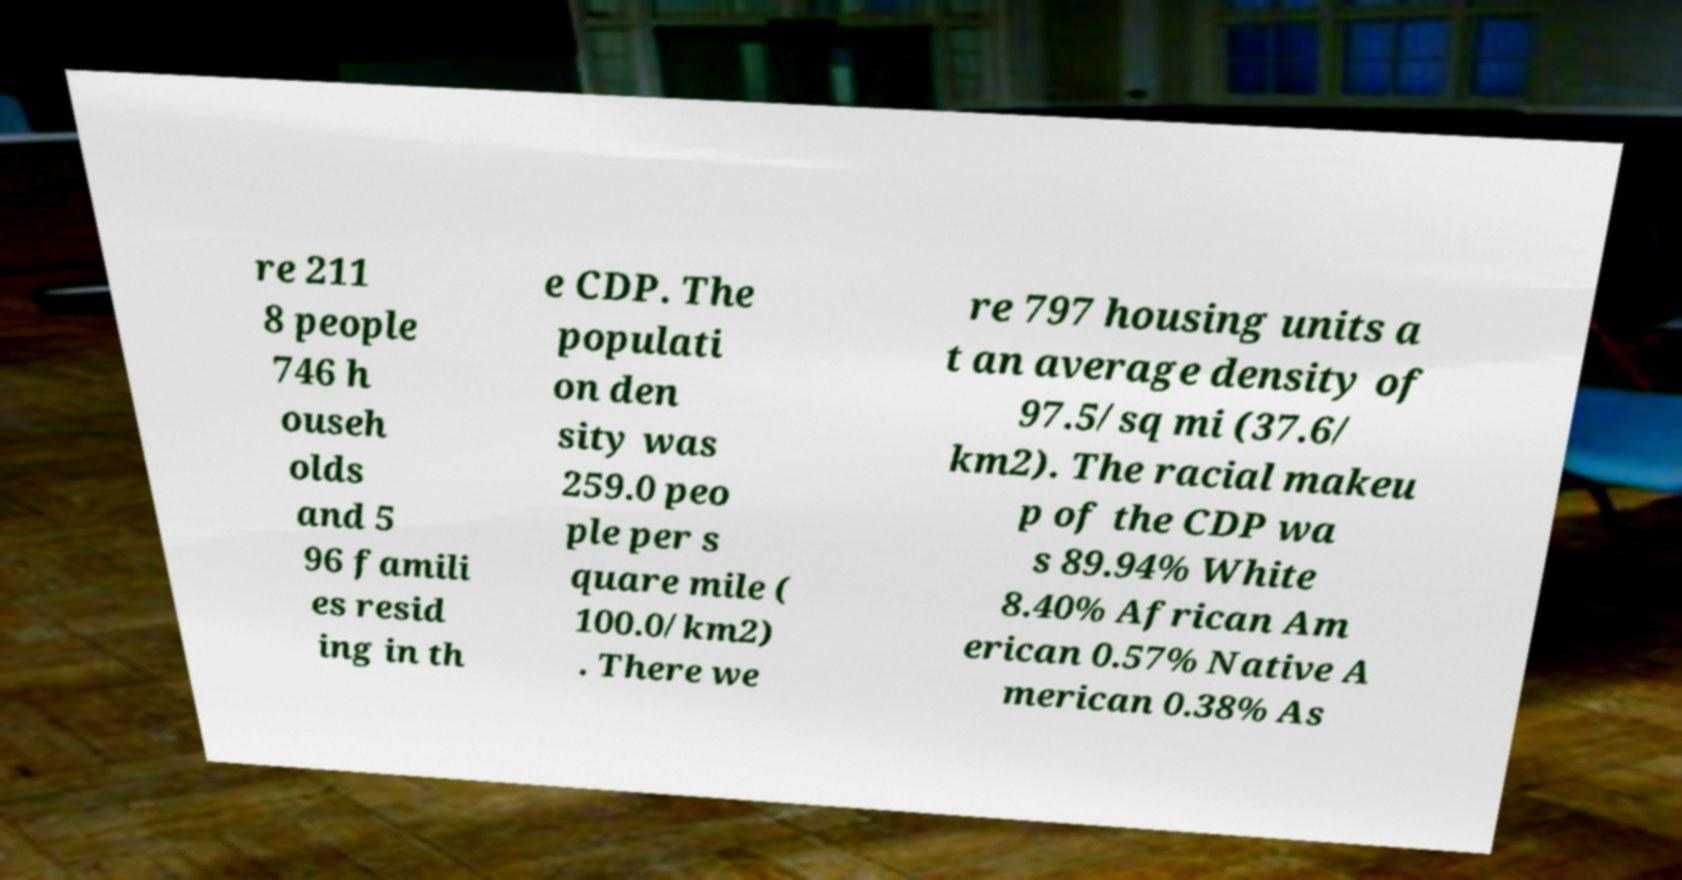Please read and relay the text visible in this image. What does it say? re 211 8 people 746 h ouseh olds and 5 96 famili es resid ing in th e CDP. The populati on den sity was 259.0 peo ple per s quare mile ( 100.0/km2) . There we re 797 housing units a t an average density of 97.5/sq mi (37.6/ km2). The racial makeu p of the CDP wa s 89.94% White 8.40% African Am erican 0.57% Native A merican 0.38% As 